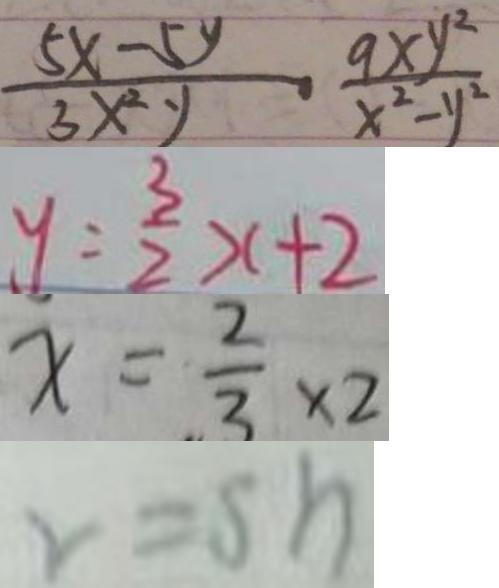<formula> <loc_0><loc_0><loc_500><loc_500>\frac { 5 x - 5 y } { 3 x ^ { 2 } y } - \frac { 9 x y ^ { 2 } } { x ^ { 2 } - y ^ { 2 } } 
 y = \frac { 3 } { 2 } x + 2 
 x = \frac { 2 } { 3 } \times 2 
 v = s h</formula> 